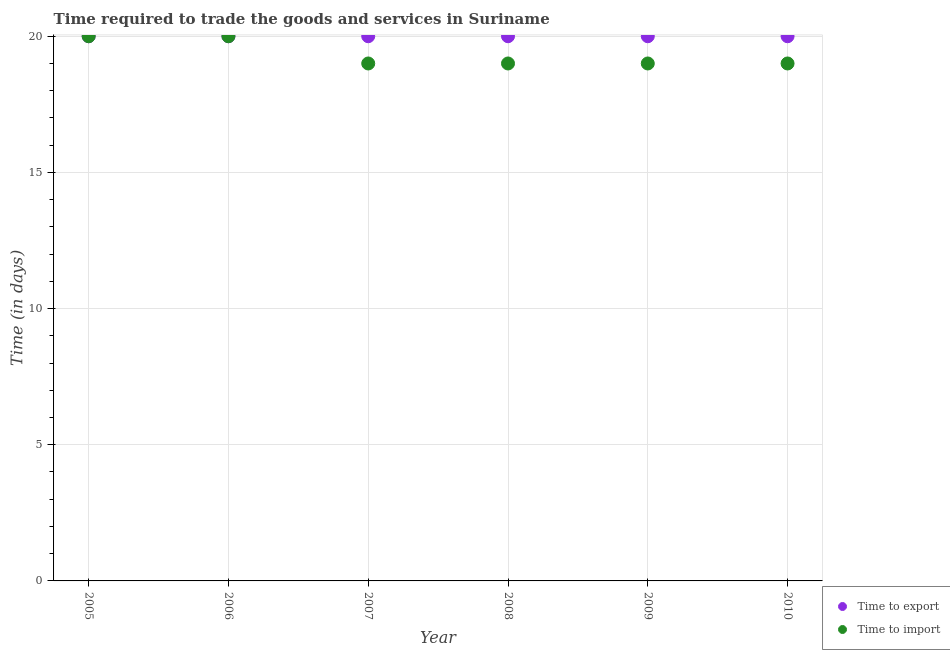Is the number of dotlines equal to the number of legend labels?
Make the answer very short. Yes. What is the time to export in 2009?
Offer a terse response. 20. Across all years, what is the maximum time to import?
Your answer should be compact. 20. Across all years, what is the minimum time to import?
Make the answer very short. 19. What is the total time to import in the graph?
Make the answer very short. 116. What is the difference between the time to import in 2007 and the time to export in 2005?
Provide a succinct answer. -1. What is the average time to export per year?
Make the answer very short. 20. In the year 2007, what is the difference between the time to export and time to import?
Keep it short and to the point. 1. In how many years, is the time to export greater than 1 days?
Your answer should be compact. 6. What is the ratio of the time to export in 2006 to that in 2010?
Keep it short and to the point. 1. Is the time to import in 2007 less than that in 2009?
Provide a succinct answer. No. Is the difference between the time to import in 2006 and 2010 greater than the difference between the time to export in 2006 and 2010?
Offer a very short reply. Yes. What is the difference between the highest and the second highest time to import?
Offer a terse response. 0. What is the difference between the highest and the lowest time to export?
Make the answer very short. 0. In how many years, is the time to export greater than the average time to export taken over all years?
Your answer should be very brief. 0. Is the sum of the time to export in 2007 and 2008 greater than the maximum time to import across all years?
Provide a succinct answer. Yes. Is the time to export strictly less than the time to import over the years?
Offer a terse response. No. How many dotlines are there?
Your response must be concise. 2. How many legend labels are there?
Offer a very short reply. 2. How are the legend labels stacked?
Offer a very short reply. Vertical. What is the title of the graph?
Keep it short and to the point. Time required to trade the goods and services in Suriname. What is the label or title of the X-axis?
Keep it short and to the point. Year. What is the label or title of the Y-axis?
Provide a short and direct response. Time (in days). What is the Time (in days) of Time to export in 2005?
Your answer should be very brief. 20. What is the Time (in days) in Time to export in 2006?
Make the answer very short. 20. What is the Time (in days) in Time to import in 2006?
Your answer should be very brief. 20. What is the Time (in days) of Time to import in 2007?
Provide a short and direct response. 19. What is the Time (in days) in Time to import in 2009?
Give a very brief answer. 19. What is the Time (in days) of Time to import in 2010?
Make the answer very short. 19. Across all years, what is the maximum Time (in days) in Time to export?
Your answer should be compact. 20. Across all years, what is the minimum Time (in days) of Time to import?
Provide a short and direct response. 19. What is the total Time (in days) in Time to export in the graph?
Provide a short and direct response. 120. What is the total Time (in days) in Time to import in the graph?
Provide a short and direct response. 116. What is the difference between the Time (in days) of Time to export in 2005 and that in 2006?
Your answer should be very brief. 0. What is the difference between the Time (in days) of Time to import in 2005 and that in 2006?
Keep it short and to the point. 0. What is the difference between the Time (in days) of Time to export in 2005 and that in 2007?
Provide a succinct answer. 0. What is the difference between the Time (in days) in Time to import in 2005 and that in 2009?
Give a very brief answer. 1. What is the difference between the Time (in days) in Time to export in 2005 and that in 2010?
Provide a short and direct response. 0. What is the difference between the Time (in days) of Time to import in 2005 and that in 2010?
Keep it short and to the point. 1. What is the difference between the Time (in days) of Time to export in 2006 and that in 2007?
Make the answer very short. 0. What is the difference between the Time (in days) of Time to import in 2006 and that in 2007?
Your answer should be compact. 1. What is the difference between the Time (in days) of Time to import in 2006 and that in 2008?
Your response must be concise. 1. What is the difference between the Time (in days) in Time to import in 2006 and that in 2010?
Your answer should be compact. 1. What is the difference between the Time (in days) of Time to export in 2007 and that in 2008?
Your answer should be compact. 0. What is the difference between the Time (in days) of Time to import in 2007 and that in 2008?
Offer a terse response. 0. What is the difference between the Time (in days) in Time to import in 2007 and that in 2009?
Ensure brevity in your answer.  0. What is the difference between the Time (in days) of Time to export in 2007 and that in 2010?
Your response must be concise. 0. What is the difference between the Time (in days) in Time to import in 2007 and that in 2010?
Ensure brevity in your answer.  0. What is the difference between the Time (in days) in Time to import in 2008 and that in 2009?
Give a very brief answer. 0. What is the difference between the Time (in days) in Time to export in 2009 and that in 2010?
Offer a terse response. 0. What is the difference between the Time (in days) in Time to export in 2005 and the Time (in days) in Time to import in 2007?
Your answer should be compact. 1. What is the difference between the Time (in days) in Time to export in 2005 and the Time (in days) in Time to import in 2008?
Keep it short and to the point. 1. What is the difference between the Time (in days) of Time to export in 2005 and the Time (in days) of Time to import in 2010?
Your response must be concise. 1. What is the difference between the Time (in days) in Time to export in 2006 and the Time (in days) in Time to import in 2007?
Your answer should be very brief. 1. What is the difference between the Time (in days) in Time to export in 2006 and the Time (in days) in Time to import in 2008?
Make the answer very short. 1. What is the difference between the Time (in days) in Time to export in 2006 and the Time (in days) in Time to import in 2009?
Your answer should be compact. 1. What is the difference between the Time (in days) of Time to export in 2006 and the Time (in days) of Time to import in 2010?
Keep it short and to the point. 1. What is the difference between the Time (in days) in Time to export in 2008 and the Time (in days) in Time to import in 2009?
Provide a succinct answer. 1. What is the average Time (in days) in Time to export per year?
Your response must be concise. 20. What is the average Time (in days) of Time to import per year?
Offer a terse response. 19.33. In the year 2005, what is the difference between the Time (in days) of Time to export and Time (in days) of Time to import?
Your response must be concise. 0. In the year 2007, what is the difference between the Time (in days) in Time to export and Time (in days) in Time to import?
Keep it short and to the point. 1. In the year 2009, what is the difference between the Time (in days) in Time to export and Time (in days) in Time to import?
Make the answer very short. 1. What is the ratio of the Time (in days) of Time to export in 2005 to that in 2006?
Provide a succinct answer. 1. What is the ratio of the Time (in days) in Time to import in 2005 to that in 2007?
Your answer should be compact. 1.05. What is the ratio of the Time (in days) in Time to export in 2005 to that in 2008?
Ensure brevity in your answer.  1. What is the ratio of the Time (in days) in Time to import in 2005 to that in 2008?
Keep it short and to the point. 1.05. What is the ratio of the Time (in days) of Time to export in 2005 to that in 2009?
Provide a short and direct response. 1. What is the ratio of the Time (in days) of Time to import in 2005 to that in 2009?
Your response must be concise. 1.05. What is the ratio of the Time (in days) in Time to import in 2005 to that in 2010?
Your response must be concise. 1.05. What is the ratio of the Time (in days) of Time to import in 2006 to that in 2007?
Provide a succinct answer. 1.05. What is the ratio of the Time (in days) of Time to export in 2006 to that in 2008?
Your answer should be very brief. 1. What is the ratio of the Time (in days) of Time to import in 2006 to that in 2008?
Ensure brevity in your answer.  1.05. What is the ratio of the Time (in days) of Time to export in 2006 to that in 2009?
Keep it short and to the point. 1. What is the ratio of the Time (in days) in Time to import in 2006 to that in 2009?
Your response must be concise. 1.05. What is the ratio of the Time (in days) in Time to export in 2006 to that in 2010?
Make the answer very short. 1. What is the ratio of the Time (in days) in Time to import in 2006 to that in 2010?
Offer a very short reply. 1.05. What is the ratio of the Time (in days) of Time to export in 2007 to that in 2008?
Keep it short and to the point. 1. What is the ratio of the Time (in days) of Time to import in 2007 to that in 2008?
Your answer should be very brief. 1. What is the ratio of the Time (in days) of Time to export in 2007 to that in 2009?
Ensure brevity in your answer.  1. What is the ratio of the Time (in days) of Time to import in 2007 to that in 2009?
Your answer should be compact. 1. What is the ratio of the Time (in days) of Time to export in 2007 to that in 2010?
Offer a very short reply. 1. What is the ratio of the Time (in days) of Time to import in 2008 to that in 2009?
Provide a succinct answer. 1. What is the ratio of the Time (in days) in Time to export in 2008 to that in 2010?
Keep it short and to the point. 1. What is the ratio of the Time (in days) of Time to import in 2008 to that in 2010?
Offer a terse response. 1. What is the ratio of the Time (in days) in Time to export in 2009 to that in 2010?
Give a very brief answer. 1. What is the ratio of the Time (in days) in Time to import in 2009 to that in 2010?
Offer a very short reply. 1. What is the difference between the highest and the second highest Time (in days) in Time to export?
Offer a terse response. 0. What is the difference between the highest and the second highest Time (in days) in Time to import?
Your answer should be compact. 0. What is the difference between the highest and the lowest Time (in days) in Time to import?
Make the answer very short. 1. 